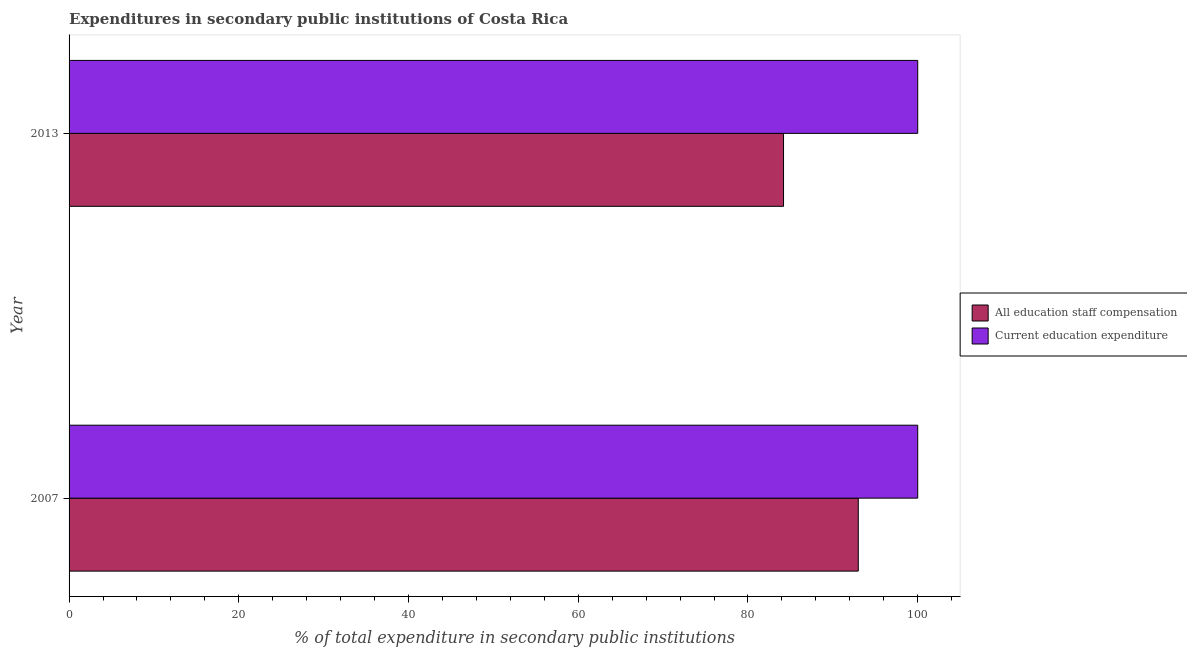How many different coloured bars are there?
Your answer should be compact. 2. How many groups of bars are there?
Provide a succinct answer. 2. How many bars are there on the 1st tick from the bottom?
Your answer should be very brief. 2. What is the expenditure in education in 2013?
Offer a very short reply. 100. Across all years, what is the maximum expenditure in education?
Offer a terse response. 100. Across all years, what is the minimum expenditure in education?
Your answer should be compact. 100. In which year was the expenditure in education maximum?
Your answer should be compact. 2007. In which year was the expenditure in education minimum?
Make the answer very short. 2007. What is the total expenditure in education in the graph?
Your answer should be compact. 200. What is the difference between the expenditure in education in 2007 and that in 2013?
Provide a succinct answer. 0. What is the difference between the expenditure in education in 2013 and the expenditure in staff compensation in 2007?
Offer a terse response. 7. What is the average expenditure in staff compensation per year?
Keep it short and to the point. 88.59. In the year 2007, what is the difference between the expenditure in education and expenditure in staff compensation?
Give a very brief answer. 7. In how many years, is the expenditure in education greater than 40 %?
Your answer should be very brief. 2. What is the ratio of the expenditure in staff compensation in 2007 to that in 2013?
Make the answer very short. 1.1. Is the expenditure in education in 2007 less than that in 2013?
Keep it short and to the point. No. What does the 2nd bar from the top in 2013 represents?
Your response must be concise. All education staff compensation. What does the 1st bar from the bottom in 2013 represents?
Offer a very short reply. All education staff compensation. Are all the bars in the graph horizontal?
Provide a succinct answer. Yes. How many years are there in the graph?
Give a very brief answer. 2. Are the values on the major ticks of X-axis written in scientific E-notation?
Your answer should be very brief. No. Where does the legend appear in the graph?
Keep it short and to the point. Center right. How many legend labels are there?
Make the answer very short. 2. What is the title of the graph?
Your answer should be very brief. Expenditures in secondary public institutions of Costa Rica. Does "Males" appear as one of the legend labels in the graph?
Your answer should be compact. No. What is the label or title of the X-axis?
Your answer should be very brief. % of total expenditure in secondary public institutions. What is the label or title of the Y-axis?
Give a very brief answer. Year. What is the % of total expenditure in secondary public institutions in All education staff compensation in 2007?
Your answer should be compact. 93. What is the % of total expenditure in secondary public institutions of All education staff compensation in 2013?
Your response must be concise. 84.19. What is the % of total expenditure in secondary public institutions in Current education expenditure in 2013?
Provide a succinct answer. 100. Across all years, what is the maximum % of total expenditure in secondary public institutions in All education staff compensation?
Offer a very short reply. 93. Across all years, what is the maximum % of total expenditure in secondary public institutions of Current education expenditure?
Keep it short and to the point. 100. Across all years, what is the minimum % of total expenditure in secondary public institutions in All education staff compensation?
Your answer should be very brief. 84.19. What is the total % of total expenditure in secondary public institutions in All education staff compensation in the graph?
Offer a terse response. 177.18. What is the difference between the % of total expenditure in secondary public institutions of All education staff compensation in 2007 and that in 2013?
Provide a succinct answer. 8.81. What is the difference between the % of total expenditure in secondary public institutions in All education staff compensation in 2007 and the % of total expenditure in secondary public institutions in Current education expenditure in 2013?
Give a very brief answer. -7. What is the average % of total expenditure in secondary public institutions in All education staff compensation per year?
Your response must be concise. 88.59. What is the average % of total expenditure in secondary public institutions in Current education expenditure per year?
Provide a succinct answer. 100. In the year 2007, what is the difference between the % of total expenditure in secondary public institutions of All education staff compensation and % of total expenditure in secondary public institutions of Current education expenditure?
Your response must be concise. -7. In the year 2013, what is the difference between the % of total expenditure in secondary public institutions in All education staff compensation and % of total expenditure in secondary public institutions in Current education expenditure?
Offer a very short reply. -15.81. What is the ratio of the % of total expenditure in secondary public institutions of All education staff compensation in 2007 to that in 2013?
Provide a succinct answer. 1.1. What is the ratio of the % of total expenditure in secondary public institutions in Current education expenditure in 2007 to that in 2013?
Offer a very short reply. 1. What is the difference between the highest and the second highest % of total expenditure in secondary public institutions of All education staff compensation?
Your response must be concise. 8.81. What is the difference between the highest and the lowest % of total expenditure in secondary public institutions of All education staff compensation?
Your answer should be compact. 8.81. 